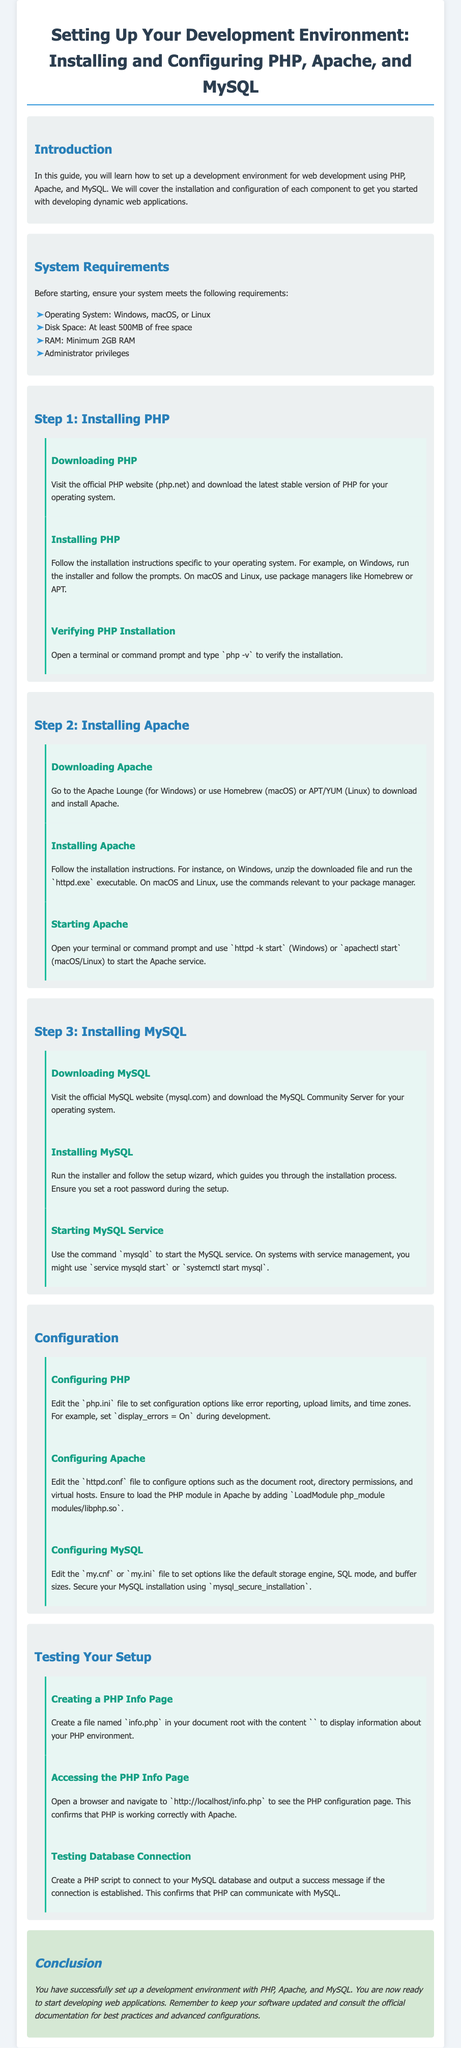What are the operating systems mentioned in the system requirements? The document lists Windows, macOS, and Linux as the operating systems for the development environment.
Answer: Windows, macOS, Linux How much disk space is required? The document states that at least 500MB of free space is needed for installation.
Answer: 500MB What command is used to verify PHP installation? The command mentioned for verifying the PHP installation is php -v as specified in the document.
Answer: php -v Which Apache executable is used to start the service on Windows? The document indicates that httpd.exe is the executable used to start the Apache service on Windows.
Answer: httpd.exe What should you set during MySQL installation? The document advises to set a root password during the MySQL setup process.
Answer: root password What file should be created to test PHP? To test PHP, the document instructs to create a file named info.php.
Answer: info.php Which command does the document suggest to start MySQL service on systems with service management? The document mentions using service mysqld start or systemctl start mysql to start the MySQL service.
Answer: service mysqld start or systemctl start mysql What should be included in the PHP Info Page? The document states to include <?php phpinfo(); ?> in the info.php file.
Answer: <?php phpinfo(); ?> What does the conclusion state about updating software? The conclusion emphasizes the importance of keeping your software updated.
Answer: keeping your software updated 